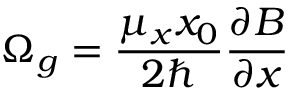Convert formula to latex. <formula><loc_0><loc_0><loc_500><loc_500>\Omega _ { g } = \frac { \mu _ { x } x _ { 0 } } { 2 } \frac { \partial B } { \partial x }</formula> 